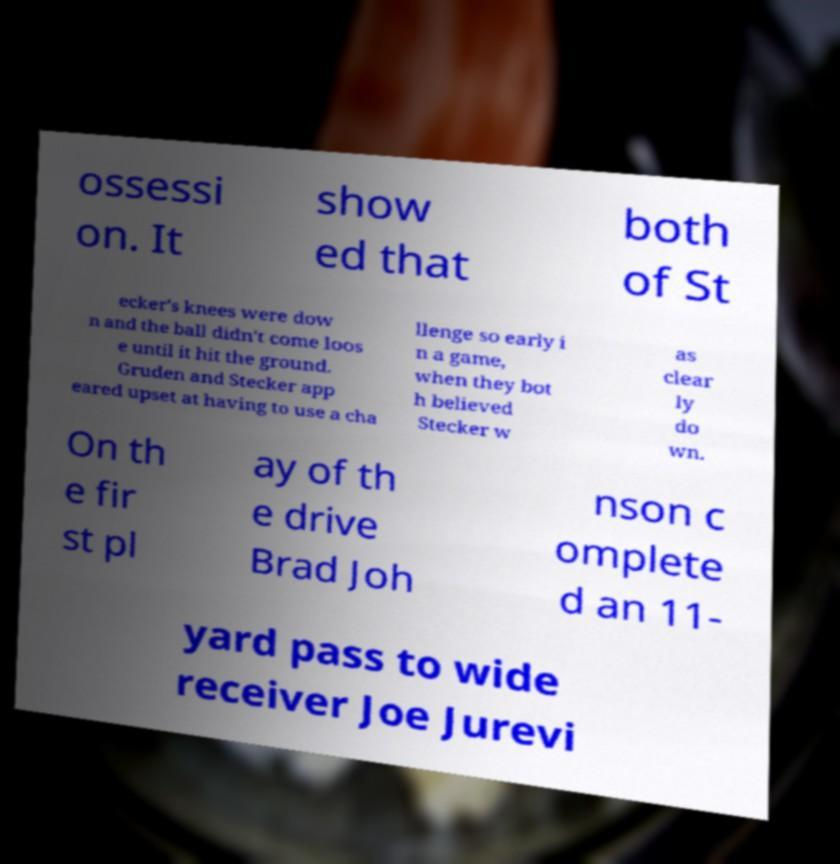There's text embedded in this image that I need extracted. Can you transcribe it verbatim? ossessi on. It show ed that both of St ecker's knees were dow n and the ball didn't come loos e until it hit the ground. Gruden and Stecker app eared upset at having to use a cha llenge so early i n a game, when they bot h believed Stecker w as clear ly do wn. On th e fir st pl ay of th e drive Brad Joh nson c omplete d an 11- yard pass to wide receiver Joe Jurevi 